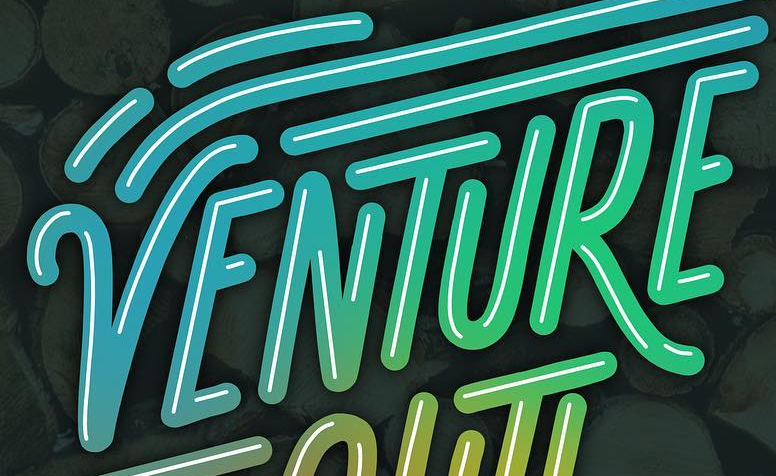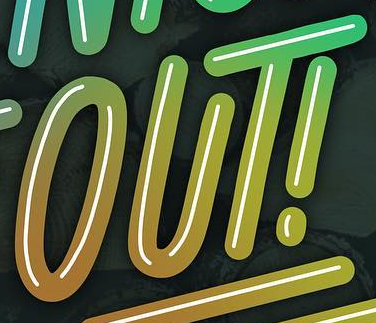Identify the words shown in these images in order, separated by a semicolon. VENTURE; OUT! 